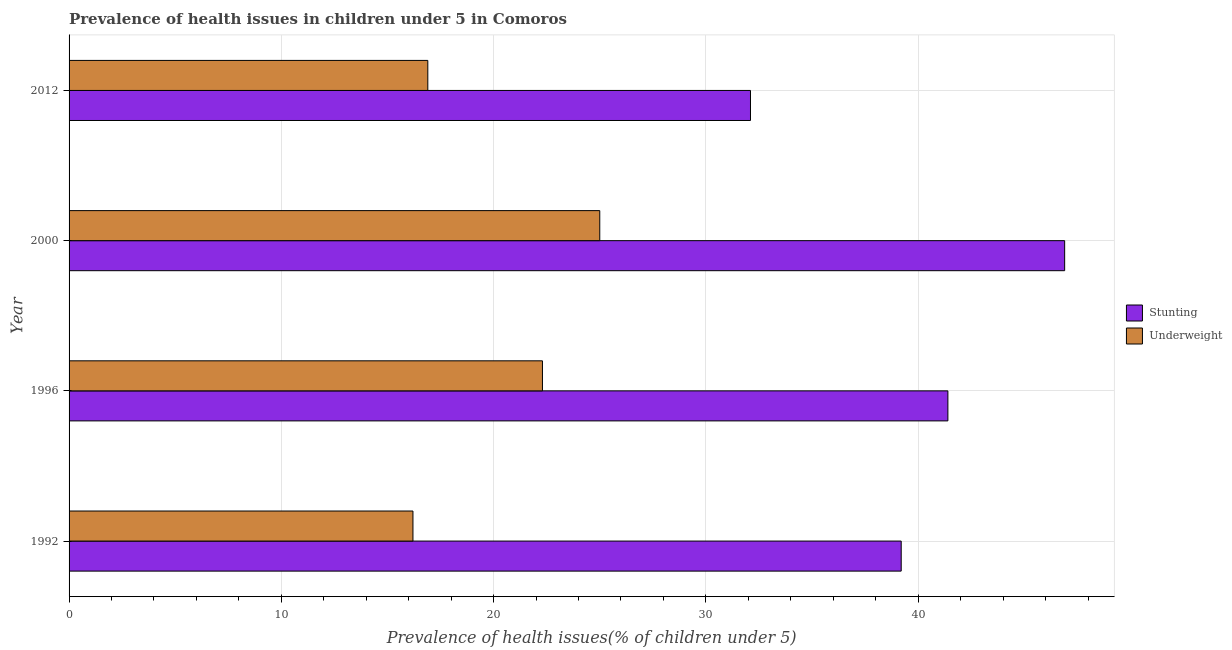How many different coloured bars are there?
Your answer should be very brief. 2. Are the number of bars per tick equal to the number of legend labels?
Give a very brief answer. Yes. Are the number of bars on each tick of the Y-axis equal?
Offer a very short reply. Yes. How many bars are there on the 2nd tick from the top?
Provide a short and direct response. 2. What is the percentage of underweight children in 2012?
Make the answer very short. 16.9. Across all years, what is the maximum percentage of stunted children?
Give a very brief answer. 46.9. Across all years, what is the minimum percentage of stunted children?
Make the answer very short. 32.1. In which year was the percentage of stunted children maximum?
Keep it short and to the point. 2000. What is the total percentage of underweight children in the graph?
Offer a terse response. 80.4. What is the difference between the percentage of stunted children in 2000 and that in 2012?
Offer a terse response. 14.8. What is the difference between the percentage of underweight children in 1992 and the percentage of stunted children in 2012?
Offer a very short reply. -15.9. What is the average percentage of stunted children per year?
Provide a short and direct response. 39.9. In the year 1992, what is the difference between the percentage of stunted children and percentage of underweight children?
Provide a short and direct response. 23. In how many years, is the percentage of stunted children greater than 44 %?
Your answer should be very brief. 1. What is the ratio of the percentage of underweight children in 1996 to that in 2000?
Offer a very short reply. 0.89. Is the sum of the percentage of underweight children in 1992 and 2000 greater than the maximum percentage of stunted children across all years?
Provide a short and direct response. No. What does the 1st bar from the top in 1992 represents?
Make the answer very short. Underweight. What does the 2nd bar from the bottom in 2012 represents?
Offer a terse response. Underweight. Are all the bars in the graph horizontal?
Ensure brevity in your answer.  Yes. What is the difference between two consecutive major ticks on the X-axis?
Give a very brief answer. 10. Does the graph contain any zero values?
Give a very brief answer. No. Does the graph contain grids?
Ensure brevity in your answer.  Yes. Where does the legend appear in the graph?
Ensure brevity in your answer.  Center right. What is the title of the graph?
Offer a terse response. Prevalence of health issues in children under 5 in Comoros. What is the label or title of the X-axis?
Offer a terse response. Prevalence of health issues(% of children under 5). What is the Prevalence of health issues(% of children under 5) of Stunting in 1992?
Your answer should be compact. 39.2. What is the Prevalence of health issues(% of children under 5) in Underweight in 1992?
Your answer should be compact. 16.2. What is the Prevalence of health issues(% of children under 5) in Stunting in 1996?
Make the answer very short. 41.4. What is the Prevalence of health issues(% of children under 5) of Underweight in 1996?
Give a very brief answer. 22.3. What is the Prevalence of health issues(% of children under 5) of Stunting in 2000?
Your answer should be very brief. 46.9. What is the Prevalence of health issues(% of children under 5) in Stunting in 2012?
Your answer should be very brief. 32.1. What is the Prevalence of health issues(% of children under 5) in Underweight in 2012?
Your answer should be very brief. 16.9. Across all years, what is the maximum Prevalence of health issues(% of children under 5) in Stunting?
Provide a succinct answer. 46.9. Across all years, what is the minimum Prevalence of health issues(% of children under 5) in Stunting?
Your answer should be very brief. 32.1. Across all years, what is the minimum Prevalence of health issues(% of children under 5) in Underweight?
Make the answer very short. 16.2. What is the total Prevalence of health issues(% of children under 5) of Stunting in the graph?
Provide a short and direct response. 159.6. What is the total Prevalence of health issues(% of children under 5) in Underweight in the graph?
Your response must be concise. 80.4. What is the difference between the Prevalence of health issues(% of children under 5) in Stunting in 1992 and that in 1996?
Offer a very short reply. -2.2. What is the difference between the Prevalence of health issues(% of children under 5) of Underweight in 1992 and that in 1996?
Provide a short and direct response. -6.1. What is the difference between the Prevalence of health issues(% of children under 5) in Stunting in 1992 and that in 2000?
Your response must be concise. -7.7. What is the difference between the Prevalence of health issues(% of children under 5) of Underweight in 1992 and that in 2000?
Give a very brief answer. -8.8. What is the difference between the Prevalence of health issues(% of children under 5) of Underweight in 1992 and that in 2012?
Your answer should be very brief. -0.7. What is the difference between the Prevalence of health issues(% of children under 5) of Underweight in 1996 and that in 2000?
Keep it short and to the point. -2.7. What is the difference between the Prevalence of health issues(% of children under 5) in Underweight in 1996 and that in 2012?
Offer a terse response. 5.4. What is the difference between the Prevalence of health issues(% of children under 5) of Stunting in 2000 and that in 2012?
Keep it short and to the point. 14.8. What is the difference between the Prevalence of health issues(% of children under 5) of Stunting in 1992 and the Prevalence of health issues(% of children under 5) of Underweight in 2012?
Your response must be concise. 22.3. What is the difference between the Prevalence of health issues(% of children under 5) of Stunting in 1996 and the Prevalence of health issues(% of children under 5) of Underweight in 2000?
Make the answer very short. 16.4. What is the difference between the Prevalence of health issues(% of children under 5) of Stunting in 2000 and the Prevalence of health issues(% of children under 5) of Underweight in 2012?
Keep it short and to the point. 30. What is the average Prevalence of health issues(% of children under 5) in Stunting per year?
Your response must be concise. 39.9. What is the average Prevalence of health issues(% of children under 5) of Underweight per year?
Ensure brevity in your answer.  20.1. In the year 2000, what is the difference between the Prevalence of health issues(% of children under 5) of Stunting and Prevalence of health issues(% of children under 5) of Underweight?
Keep it short and to the point. 21.9. What is the ratio of the Prevalence of health issues(% of children under 5) of Stunting in 1992 to that in 1996?
Provide a short and direct response. 0.95. What is the ratio of the Prevalence of health issues(% of children under 5) in Underweight in 1992 to that in 1996?
Offer a very short reply. 0.73. What is the ratio of the Prevalence of health issues(% of children under 5) in Stunting in 1992 to that in 2000?
Your answer should be compact. 0.84. What is the ratio of the Prevalence of health issues(% of children under 5) in Underweight in 1992 to that in 2000?
Make the answer very short. 0.65. What is the ratio of the Prevalence of health issues(% of children under 5) of Stunting in 1992 to that in 2012?
Your response must be concise. 1.22. What is the ratio of the Prevalence of health issues(% of children under 5) in Underweight in 1992 to that in 2012?
Your answer should be very brief. 0.96. What is the ratio of the Prevalence of health issues(% of children under 5) of Stunting in 1996 to that in 2000?
Keep it short and to the point. 0.88. What is the ratio of the Prevalence of health issues(% of children under 5) of Underweight in 1996 to that in 2000?
Offer a very short reply. 0.89. What is the ratio of the Prevalence of health issues(% of children under 5) of Stunting in 1996 to that in 2012?
Your response must be concise. 1.29. What is the ratio of the Prevalence of health issues(% of children under 5) in Underweight in 1996 to that in 2012?
Your answer should be compact. 1.32. What is the ratio of the Prevalence of health issues(% of children under 5) of Stunting in 2000 to that in 2012?
Your answer should be very brief. 1.46. What is the ratio of the Prevalence of health issues(% of children under 5) of Underweight in 2000 to that in 2012?
Your response must be concise. 1.48. What is the difference between the highest and the second highest Prevalence of health issues(% of children under 5) in Stunting?
Your answer should be very brief. 5.5. What is the difference between the highest and the second highest Prevalence of health issues(% of children under 5) of Underweight?
Offer a very short reply. 2.7. 